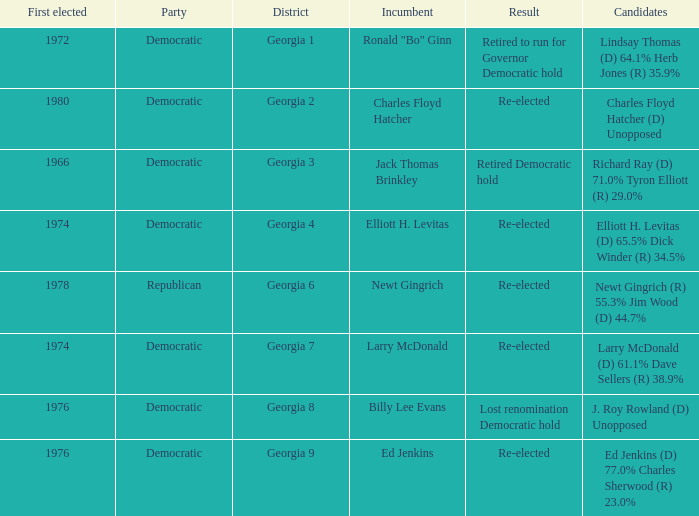Name the districk for larry mcdonald Georgia 7. 